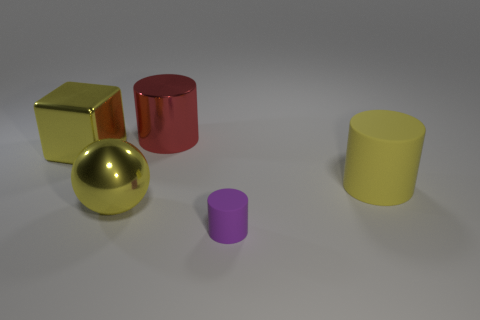Subtract all matte cylinders. How many cylinders are left? 1 Subtract all yellow cylinders. How many cylinders are left? 2 Subtract all cylinders. How many objects are left? 2 Add 3 yellow rubber cylinders. How many objects exist? 8 Subtract 1 blocks. How many blocks are left? 0 Subtract all yellow blocks. Subtract all large red things. How many objects are left? 3 Add 3 spheres. How many spheres are left? 4 Add 1 yellow shiny things. How many yellow shiny things exist? 3 Subtract 1 red cylinders. How many objects are left? 4 Subtract all gray cylinders. Subtract all brown spheres. How many cylinders are left? 3 